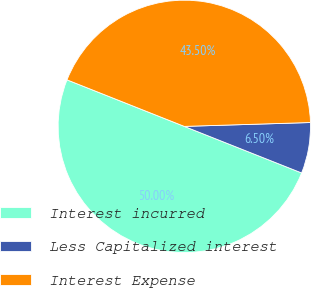Convert chart. <chart><loc_0><loc_0><loc_500><loc_500><pie_chart><fcel>Interest incurred<fcel>Less Capitalized interest<fcel>Interest Expense<nl><fcel>50.0%<fcel>6.5%<fcel>43.5%<nl></chart> 